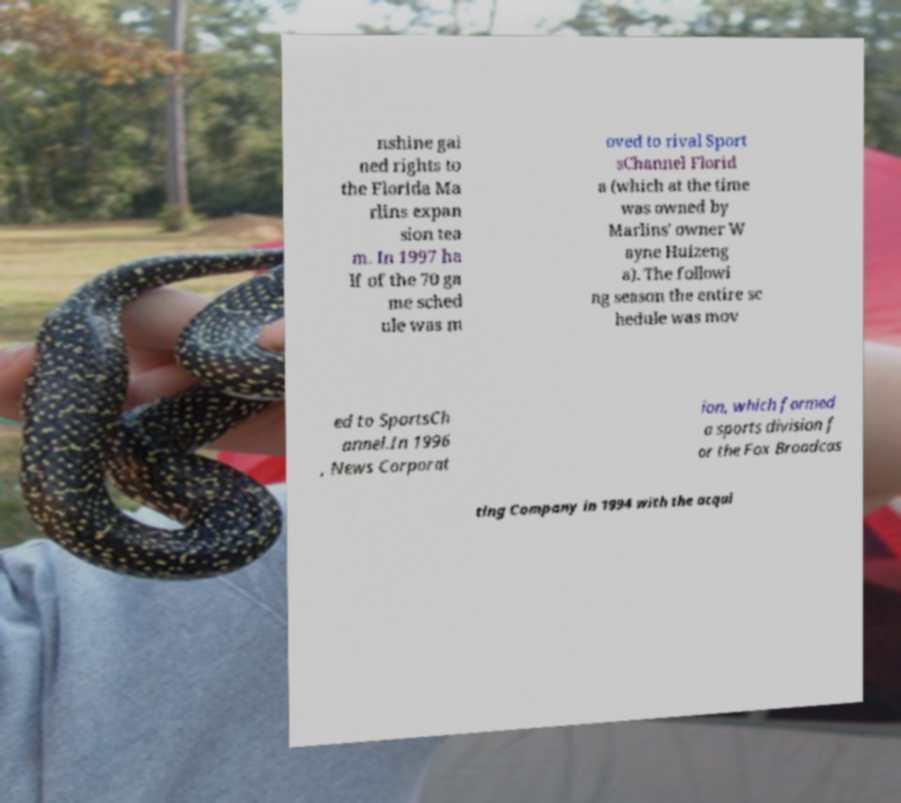Can you accurately transcribe the text from the provided image for me? nshine gai ned rights to the Florida Ma rlins expan sion tea m. In 1997 ha lf of the 70 ga me sched ule was m oved to rival Sport sChannel Florid a (which at the time was owned by Marlins' owner W ayne Huizeng a). The followi ng season the entire sc hedule was mov ed to SportsCh annel.In 1996 , News Corporat ion, which formed a sports division f or the Fox Broadcas ting Company in 1994 with the acqui 